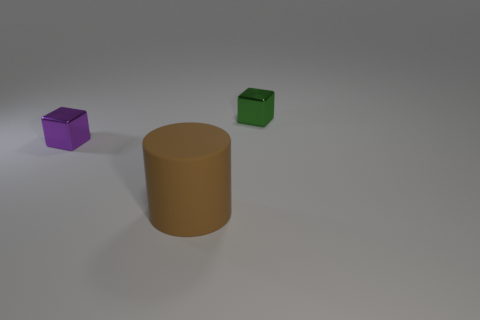Add 2 purple shiny things. How many objects exist? 5 Subtract all cubes. How many objects are left? 1 Subtract 0 blue balls. How many objects are left? 3 Subtract all purple objects. Subtract all green metal cubes. How many objects are left? 1 Add 3 big brown objects. How many big brown objects are left? 4 Add 1 big gray metallic things. How many big gray metallic things exist? 1 